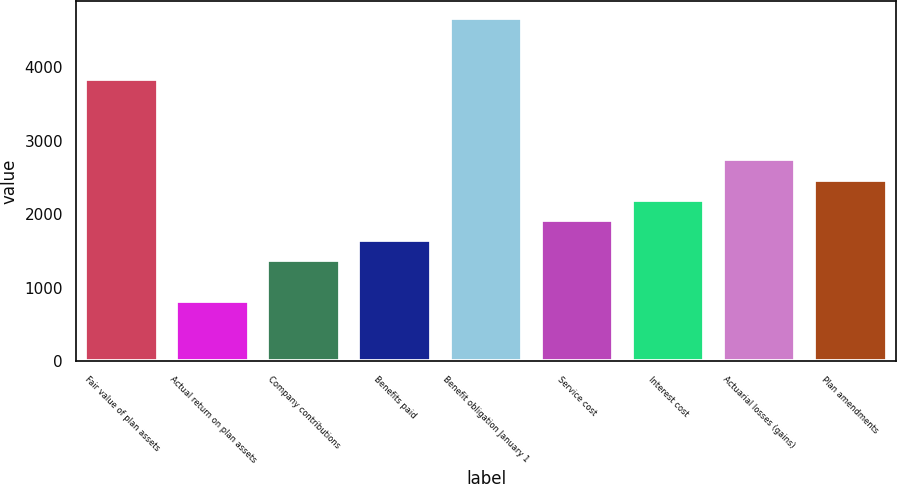<chart> <loc_0><loc_0><loc_500><loc_500><bar_chart><fcel>Fair value of plan assets<fcel>Actual return on plan assets<fcel>Company contributions<fcel>Benefits paid<fcel>Benefit obligation January 1<fcel>Service cost<fcel>Interest cost<fcel>Actuarial losses (gains)<fcel>Plan amendments<nl><fcel>3842.2<fcel>824.9<fcel>1373.5<fcel>1647.8<fcel>4665.1<fcel>1922.1<fcel>2196.4<fcel>2745<fcel>2470.7<nl></chart> 